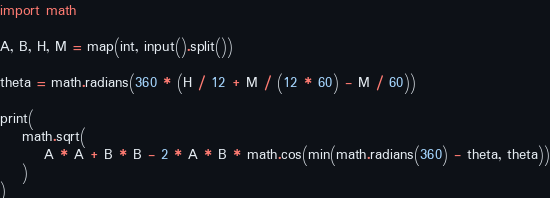<code> <loc_0><loc_0><loc_500><loc_500><_Python_>import math

A, B, H, M = map(int, input().split())

theta = math.radians(360 * (H / 12 + M / (12 * 60) - M / 60))

print(
    math.sqrt(
        A * A + B * B - 2 * A * B * math.cos(min(math.radians(360) - theta, theta))
    )
)
</code> 